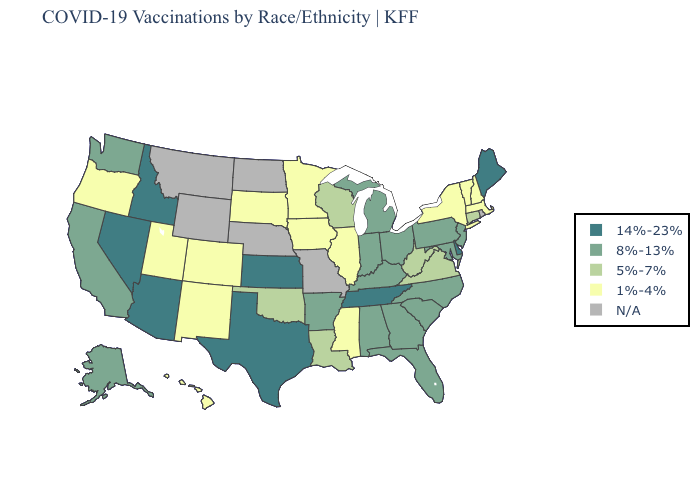Name the states that have a value in the range N/A?
Answer briefly. Missouri, Montana, Nebraska, North Dakota, Rhode Island, Wyoming. Which states have the highest value in the USA?
Give a very brief answer. Arizona, Delaware, Idaho, Kansas, Maine, Nevada, Tennessee, Texas. Name the states that have a value in the range 14%-23%?
Keep it brief. Arizona, Delaware, Idaho, Kansas, Maine, Nevada, Tennessee, Texas. Which states have the lowest value in the USA?
Give a very brief answer. Colorado, Hawaii, Illinois, Iowa, Massachusetts, Minnesota, Mississippi, New Hampshire, New Mexico, New York, Oregon, South Dakota, Utah, Vermont. Does Louisiana have the lowest value in the USA?
Write a very short answer. No. Which states have the lowest value in the West?
Concise answer only. Colorado, Hawaii, New Mexico, Oregon, Utah. Does Virginia have the lowest value in the USA?
Keep it brief. No. Which states have the highest value in the USA?
Write a very short answer. Arizona, Delaware, Idaho, Kansas, Maine, Nevada, Tennessee, Texas. How many symbols are there in the legend?
Keep it brief. 5. Name the states that have a value in the range 8%-13%?
Concise answer only. Alabama, Alaska, Arkansas, California, Florida, Georgia, Indiana, Kentucky, Maryland, Michigan, New Jersey, North Carolina, Ohio, Pennsylvania, South Carolina, Washington. Which states hav the highest value in the South?
Be succinct. Delaware, Tennessee, Texas. Name the states that have a value in the range 8%-13%?
Write a very short answer. Alabama, Alaska, Arkansas, California, Florida, Georgia, Indiana, Kentucky, Maryland, Michigan, New Jersey, North Carolina, Ohio, Pennsylvania, South Carolina, Washington. Does Nevada have the highest value in the USA?
Short answer required. Yes. 